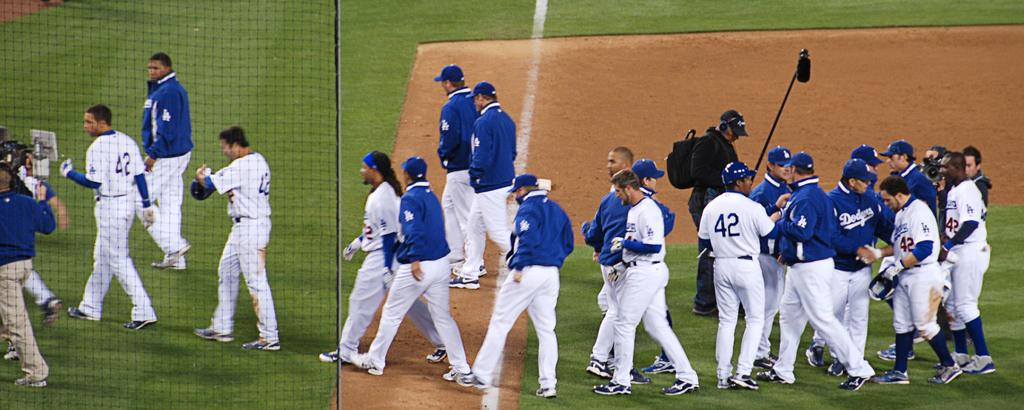<image>
Give a short and clear explanation of the subsequent image. some baseball players with one wearing 42 on their jersey 